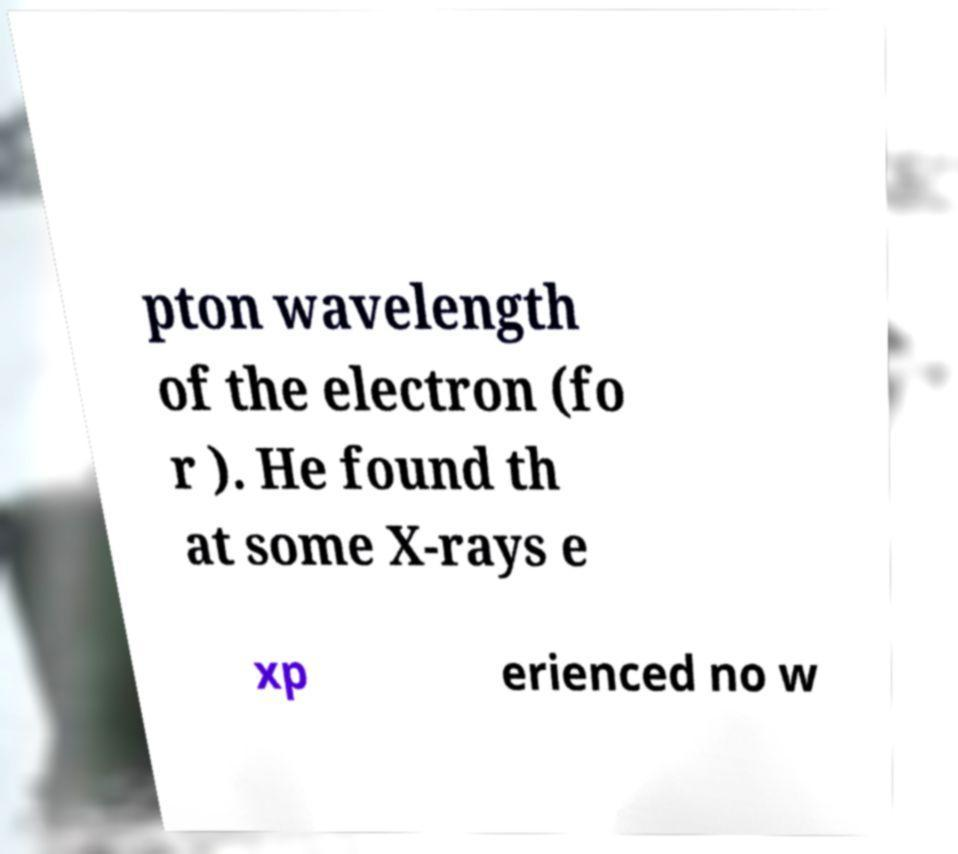For documentation purposes, I need the text within this image transcribed. Could you provide that? pton wavelength of the electron (fo r ). He found th at some X-rays e xp erienced no w 